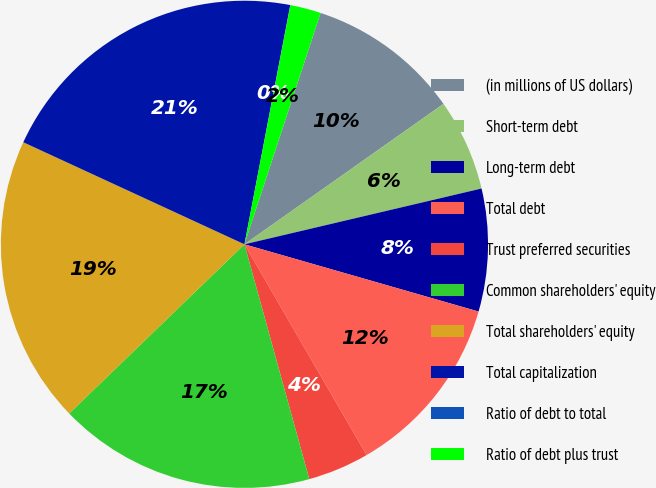Convert chart. <chart><loc_0><loc_0><loc_500><loc_500><pie_chart><fcel>(in millions of US dollars)<fcel>Short-term debt<fcel>Long-term debt<fcel>Total debt<fcel>Trust preferred securities<fcel>Common shareholders' equity<fcel>Total shareholders' equity<fcel>Total capitalization<fcel>Ratio of debt to total<fcel>Ratio of debt plus trust<nl><fcel>10.16%<fcel>6.1%<fcel>8.13%<fcel>12.19%<fcel>4.07%<fcel>17.07%<fcel>19.1%<fcel>21.13%<fcel>0.01%<fcel>2.04%<nl></chart> 